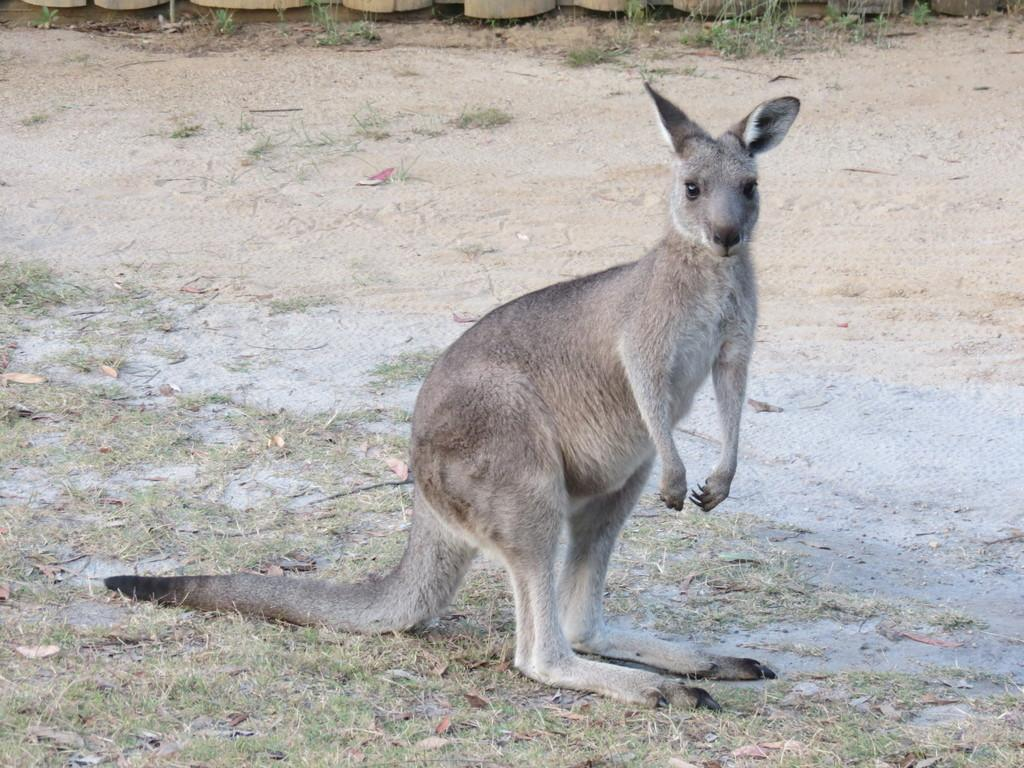What can be seen in the foreground of the picture? In the foreground of the picture, there are dry leaves, grass, and a kangaroo. What type of terrain is visible in the middle of the picture? There is sand in the middle of the picture. What is present at the top of the picture? At the top of the picture, there are wooden objects and grass. How many friends does the kangaroo have in the picture? There is no indication of friends in the picture; it only shows a kangaroo in the foreground. Can you tell me if the kangaroo is experiencing knee pain in the picture? There is no information about the kangaroo's physical condition, including any potential knee pain, in the picture. 